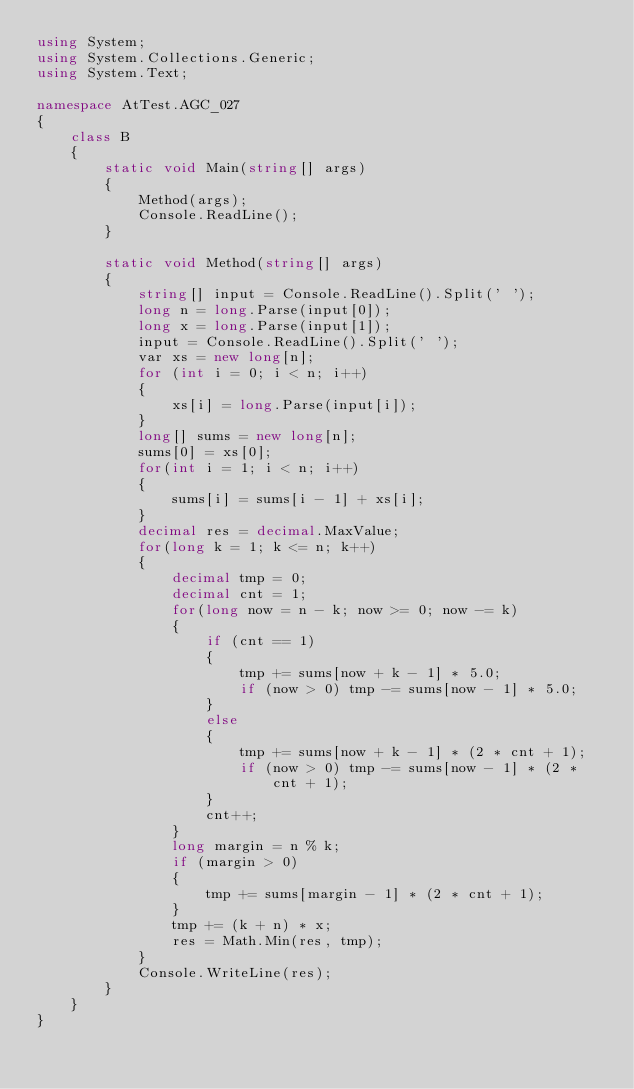Convert code to text. <code><loc_0><loc_0><loc_500><loc_500><_C#_>using System;
using System.Collections.Generic;
using System.Text;

namespace AtTest.AGC_027
{
    class B
    {
        static void Main(string[] args)
        {
            Method(args);
            Console.ReadLine();
        }

        static void Method(string[] args)
        {
            string[] input = Console.ReadLine().Split(' ');
            long n = long.Parse(input[0]);
            long x = long.Parse(input[1]);
            input = Console.ReadLine().Split(' ');
            var xs = new long[n];
            for (int i = 0; i < n; i++)
            {
                xs[i] = long.Parse(input[i]);
            }
            long[] sums = new long[n];
            sums[0] = xs[0];
            for(int i = 1; i < n; i++)
            {
                sums[i] = sums[i - 1] + xs[i];
            }
            decimal res = decimal.MaxValue;
            for(long k = 1; k <= n; k++)
            {
                decimal tmp = 0;
                decimal cnt = 1;
                for(long now = n - k; now >= 0; now -= k)
                {
                    if (cnt == 1)
                    {
                        tmp += sums[now + k - 1] * 5.0;
                        if (now > 0) tmp -= sums[now - 1] * 5.0;
                    }
                    else
                    {
                        tmp += sums[now + k - 1] * (2 * cnt + 1);
                        if (now > 0) tmp -= sums[now - 1] * (2 * cnt + 1);
                    }
                    cnt++;
                }
                long margin = n % k;
                if (margin > 0)
                {
                    tmp += sums[margin - 1] * (2 * cnt + 1);
                }
                tmp += (k + n) * x;
                res = Math.Min(res, tmp);
            }
            Console.WriteLine(res);
        }
    }
}
</code> 